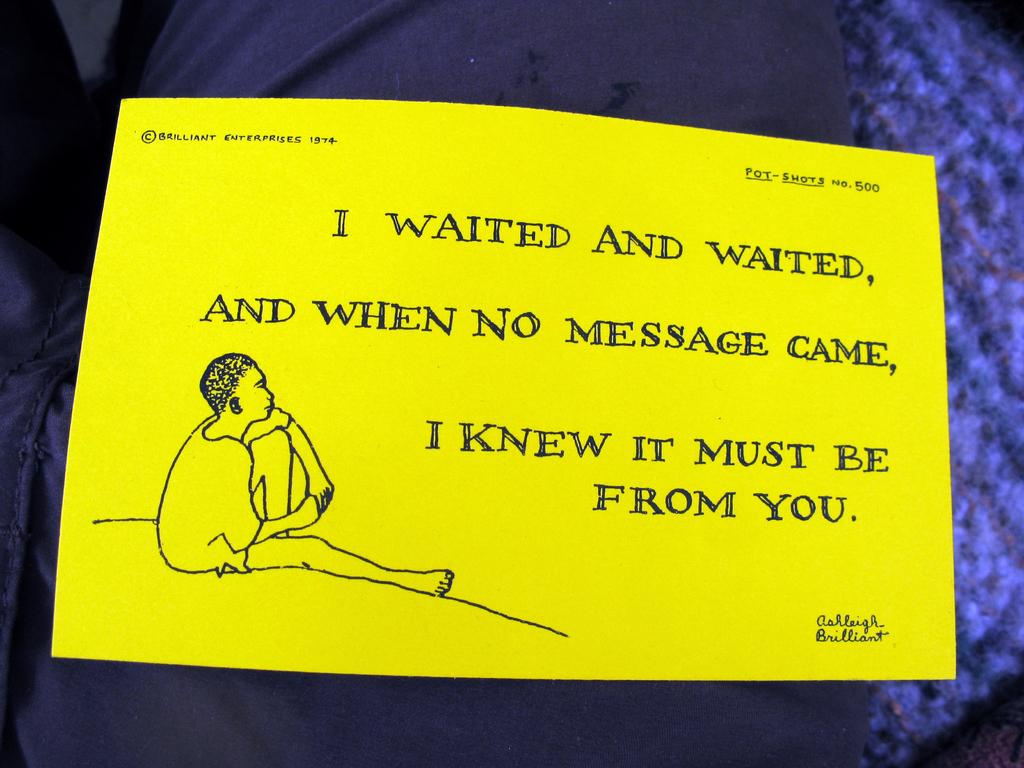What color is the note that is visible in the image? The note is yellow. What is written on the yellow note? There is text written on the yellow note. How many ducks are swimming in the water near the yellow note? There are no ducks present in the image; it only features a yellow note with text. What type of machine is being used to write the text on the yellow note? There is no machine visible in the image; the text is likely handwritten. 